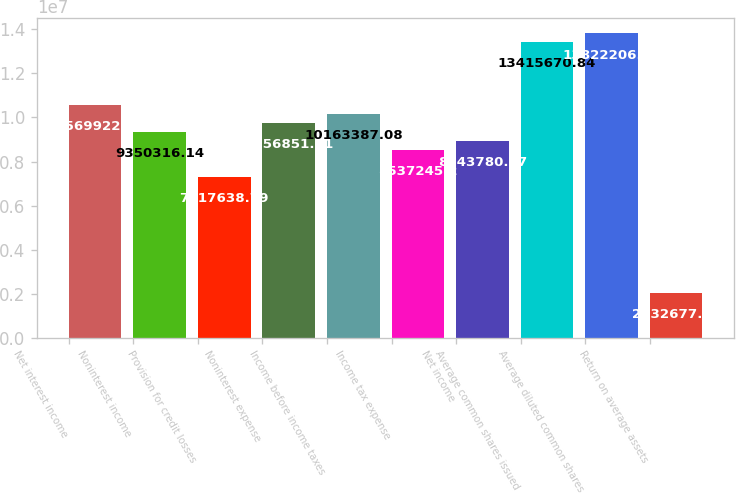Convert chart. <chart><loc_0><loc_0><loc_500><loc_500><bar_chart><fcel>Net interest income<fcel>Noninterest income<fcel>Provision for credit losses<fcel>Noninterest expense<fcel>Income before income taxes<fcel>Income tax expense<fcel>Net income<fcel>Average common shares issued<fcel>Average diluted common shares<fcel>Return on average assets<nl><fcel>1.05699e+07<fcel>9.35032e+06<fcel>7.31764e+06<fcel>9.75685e+06<fcel>1.01634e+07<fcel>8.53725e+06<fcel>8.94378e+06<fcel>1.34157e+07<fcel>1.38222e+07<fcel>2.03268e+06<nl></chart> 